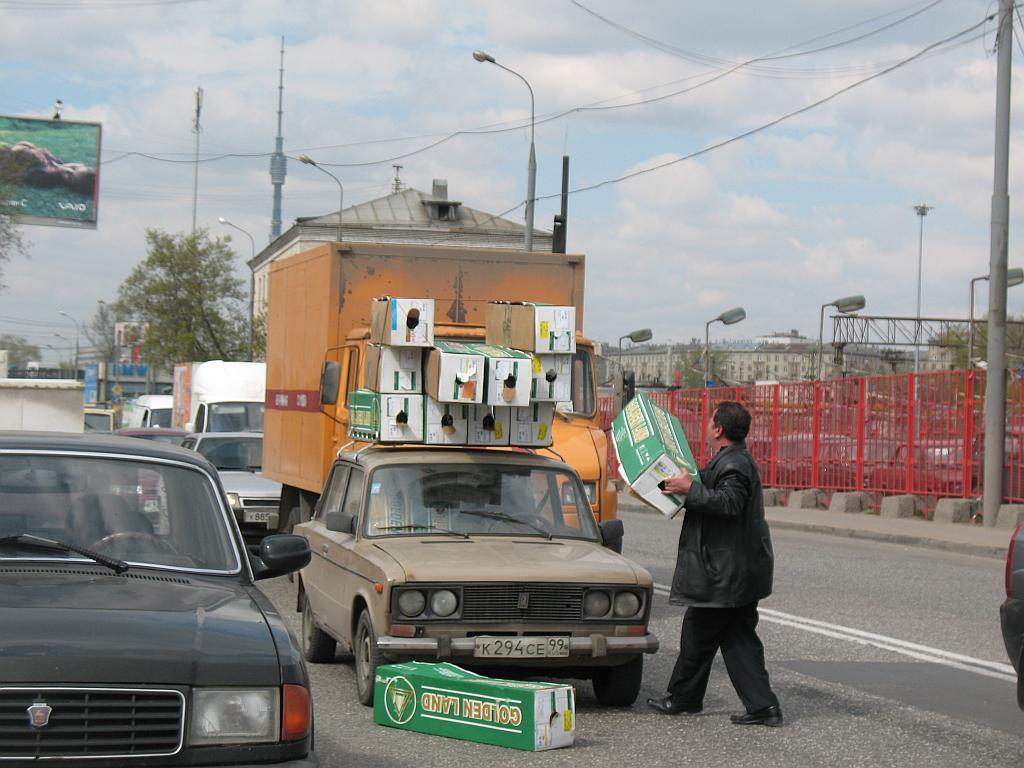In one or two sentences, can you explain what this image depicts? This image consists of a man holding the boxes which are made up of cardboard. Some of the boxes are kept on the top of a car. At the bottom, there is a road. In the front, there are many vehicles. On the right, there is a fencing along with lights and poles. In the background, there is a building along with a tree. On the left, there is a tree. At the top, there are clouds in the sky. 